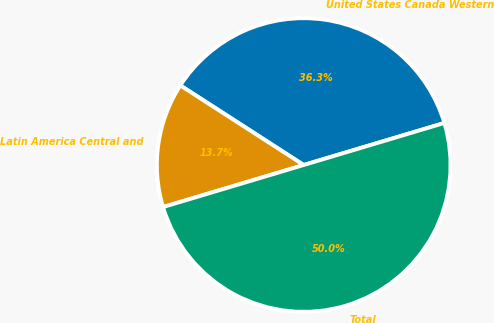Convert chart. <chart><loc_0><loc_0><loc_500><loc_500><pie_chart><fcel>United States Canada Western<fcel>Latin America Central and<fcel>Total<nl><fcel>36.26%<fcel>13.74%<fcel>50.0%<nl></chart> 